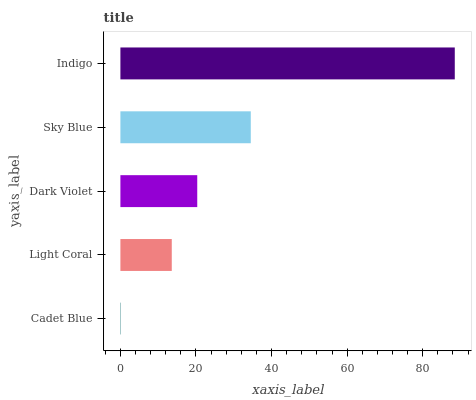Is Cadet Blue the minimum?
Answer yes or no. Yes. Is Indigo the maximum?
Answer yes or no. Yes. Is Light Coral the minimum?
Answer yes or no. No. Is Light Coral the maximum?
Answer yes or no. No. Is Light Coral greater than Cadet Blue?
Answer yes or no. Yes. Is Cadet Blue less than Light Coral?
Answer yes or no. Yes. Is Cadet Blue greater than Light Coral?
Answer yes or no. No. Is Light Coral less than Cadet Blue?
Answer yes or no. No. Is Dark Violet the high median?
Answer yes or no. Yes. Is Dark Violet the low median?
Answer yes or no. Yes. Is Indigo the high median?
Answer yes or no. No. Is Sky Blue the low median?
Answer yes or no. No. 